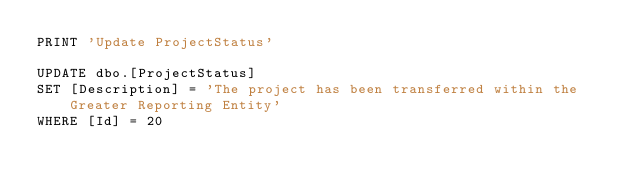<code> <loc_0><loc_0><loc_500><loc_500><_SQL_>PRINT 'Update ProjectStatus'

UPDATE dbo.[ProjectStatus]
SET [Description] = 'The project has been transferred within the Greater Reporting Entity'
WHERE [Id] = 20
</code> 